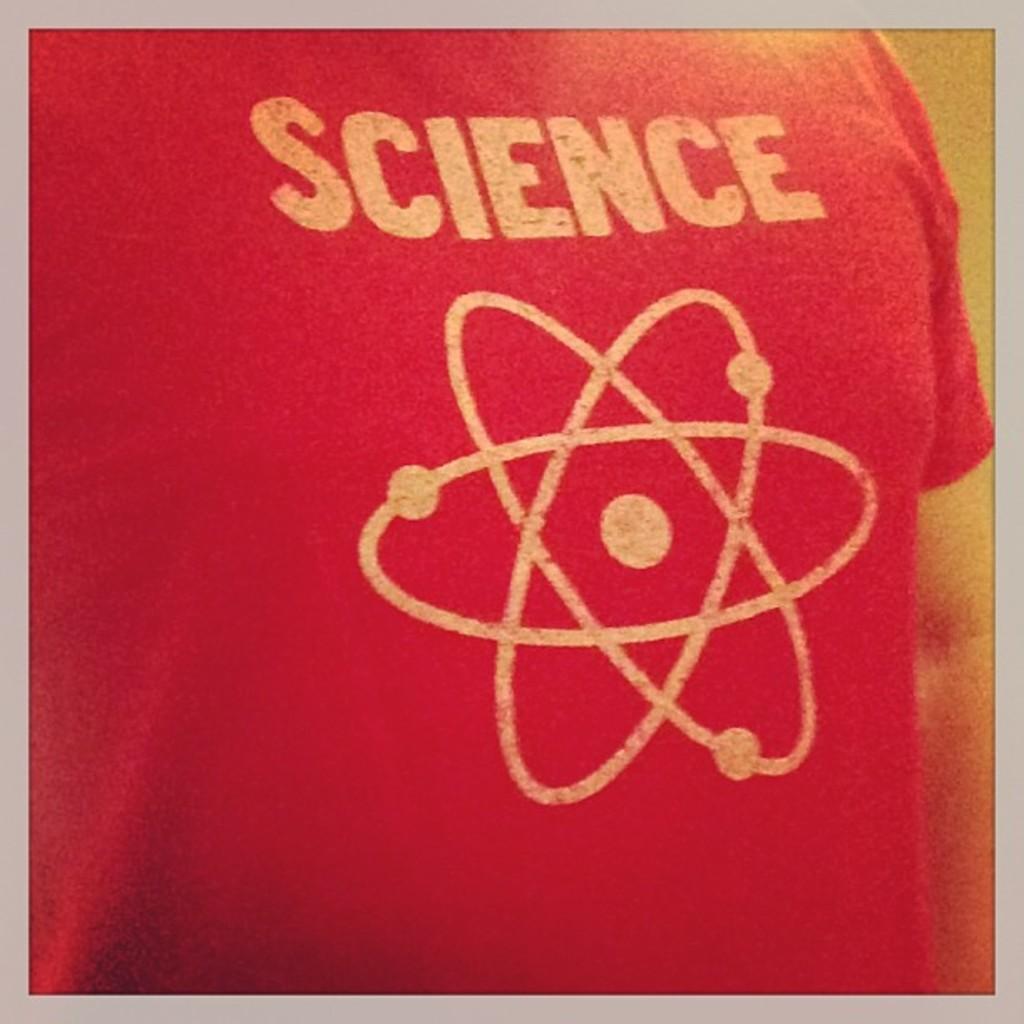What is on the shirt?
Make the answer very short. Science. What school subject is written on this shirt?
Give a very brief answer. Science. 